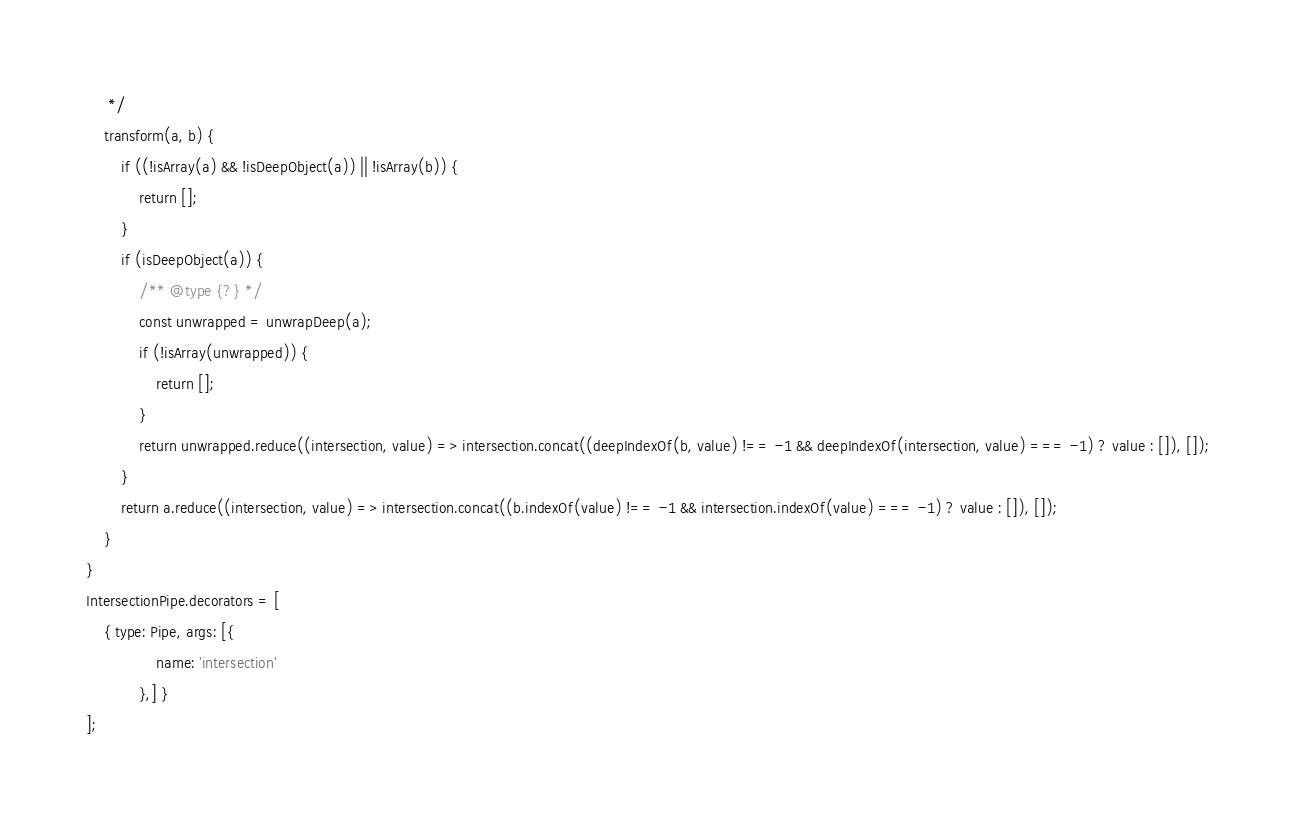<code> <loc_0><loc_0><loc_500><loc_500><_JavaScript_>     */
    transform(a, b) {
        if ((!isArray(a) && !isDeepObject(a)) || !isArray(b)) {
            return [];
        }
        if (isDeepObject(a)) {
            /** @type {?} */
            const unwrapped = unwrapDeep(a);
            if (!isArray(unwrapped)) {
                return [];
            }
            return unwrapped.reduce((intersection, value) => intersection.concat((deepIndexOf(b, value) !== -1 && deepIndexOf(intersection, value) === -1) ? value : []), []);
        }
        return a.reduce((intersection, value) => intersection.concat((b.indexOf(value) !== -1 && intersection.indexOf(value) === -1) ? value : []), []);
    }
}
IntersectionPipe.decorators = [
    { type: Pipe, args: [{
                name: 'intersection'
            },] }
];</code> 